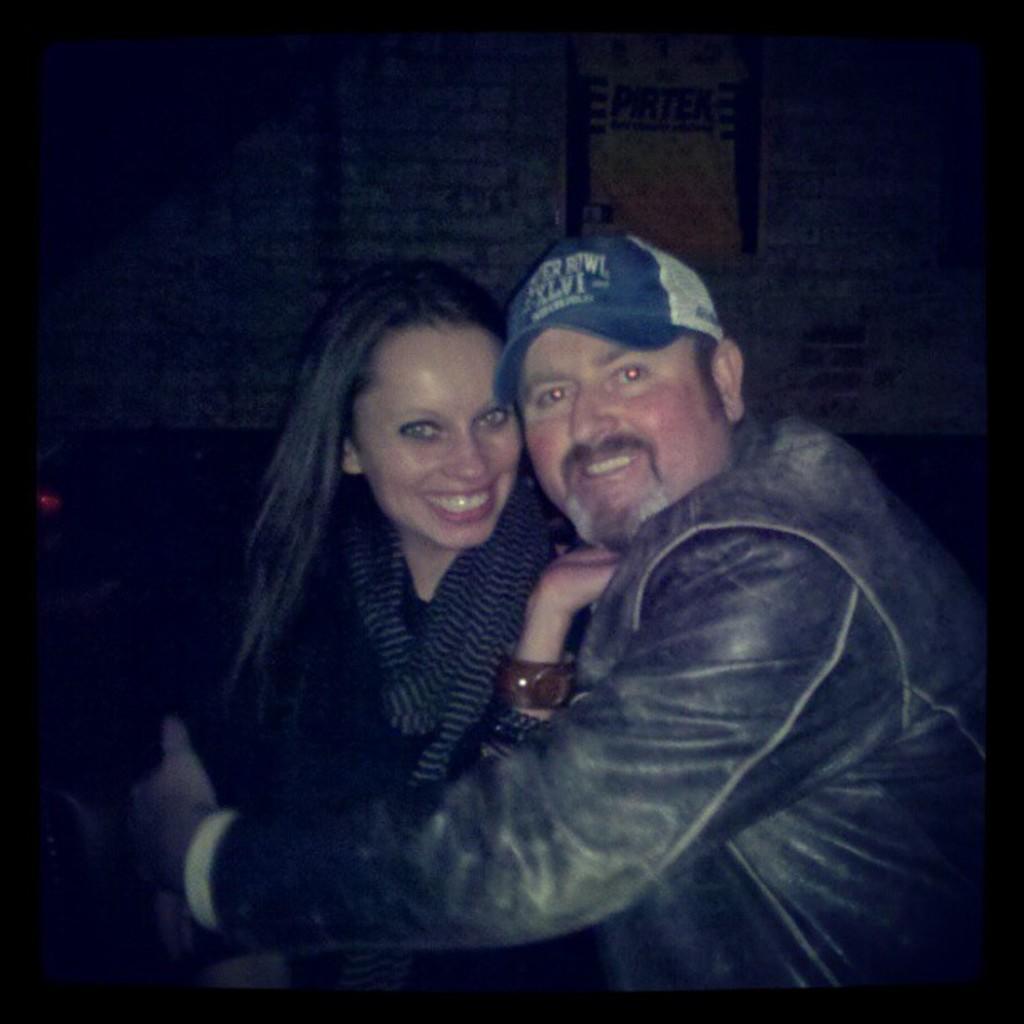Describe this image in one or two sentences. To the right side of the image there is a man with black jacket is standing and there is a blue and white cap on his head. He is holding the lady in his hands. And the lady is wearing the black dress is sitting and she is smiling. Behind them there is a white wall with a poster on it. 